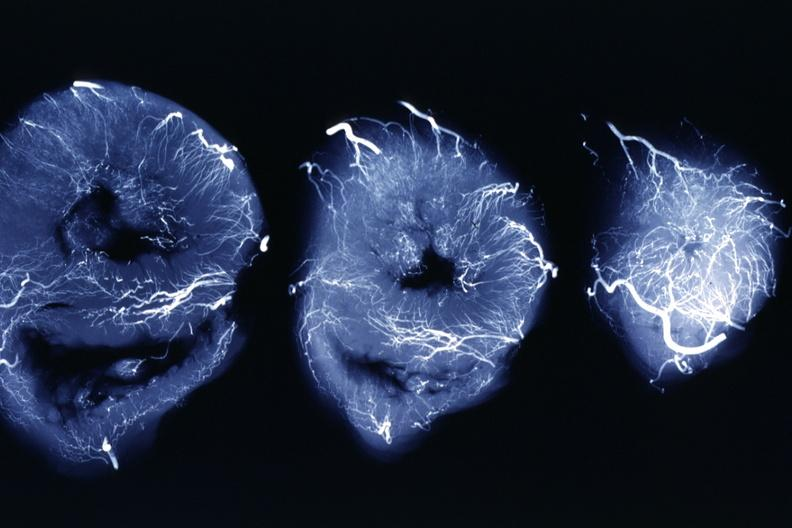s cardiovascular present?
Answer the question using a single word or phrase. Yes 